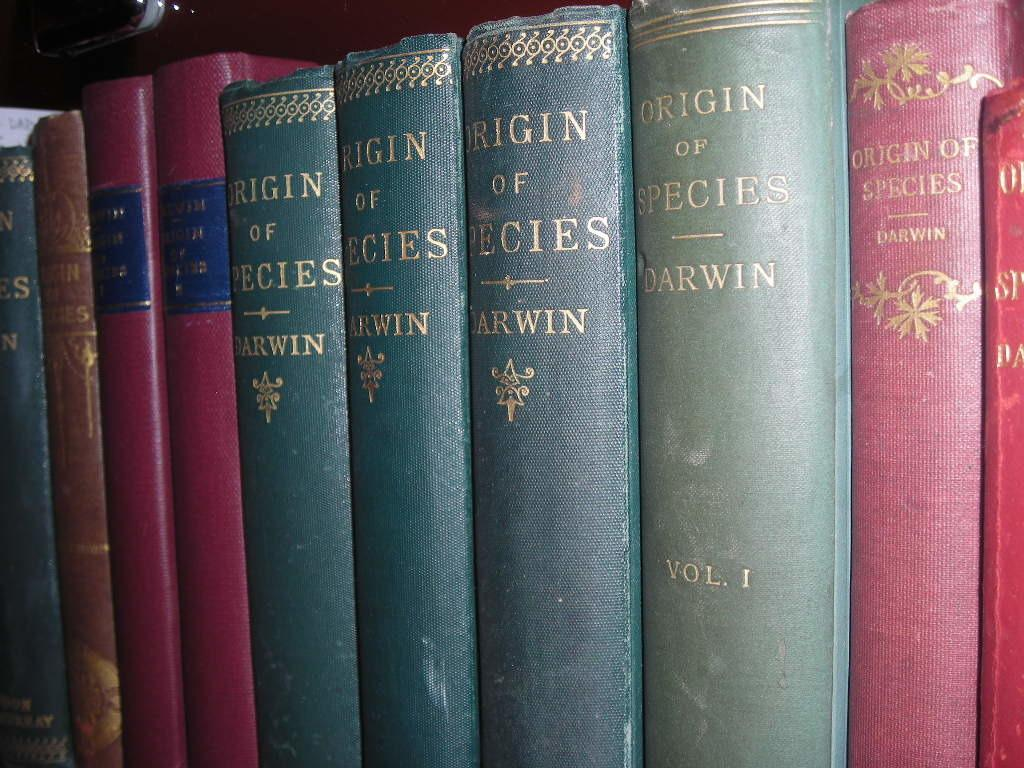Provide a one-sentence caption for the provided image. old leather bound books like Origin of the Species. 